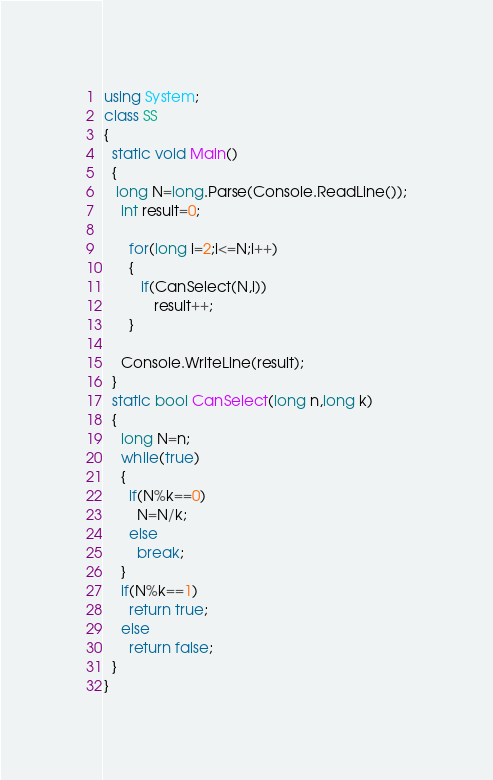<code> <loc_0><loc_0><loc_500><loc_500><_C#_>using System;
class SS
{
  static void Main()
  {
   long N=long.Parse(Console.ReadLine());
    int result=0;
   
   	  for(long i=2;i<=N;i++)
   	  {
    	 if(CanSelect(N,i))
       		result++;
   	  }
    
    Console.WriteLine(result);
  }
  static bool CanSelect(long n,long k)
  {
    long N=n;
    while(true)
    {
      if(N%k==0)
        N=N/k;
      else
        break;
    }
    if(N%k==1)
      return true;
    else
      return false;
  }
}</code> 